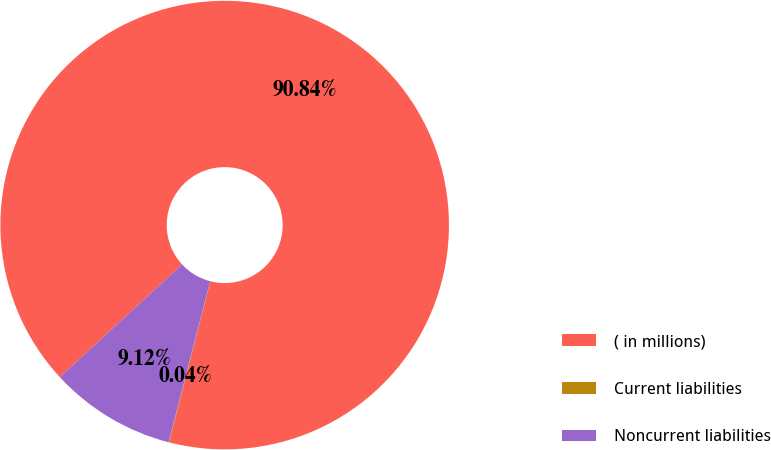Convert chart. <chart><loc_0><loc_0><loc_500><loc_500><pie_chart><fcel>( in millions)<fcel>Current liabilities<fcel>Noncurrent liabilities<nl><fcel>90.84%<fcel>0.04%<fcel>9.12%<nl></chart> 